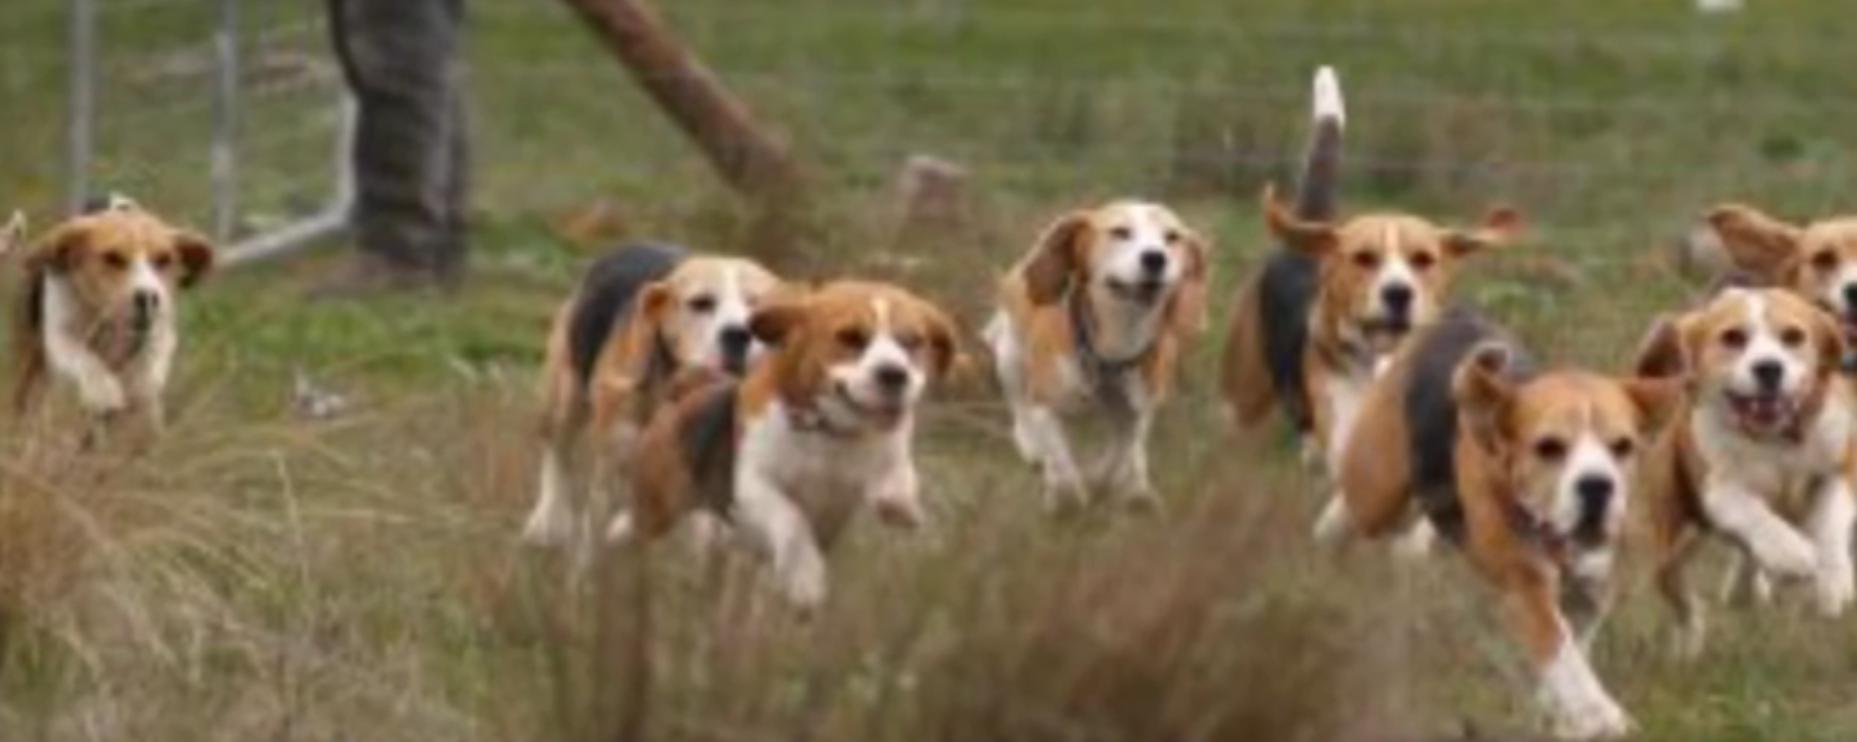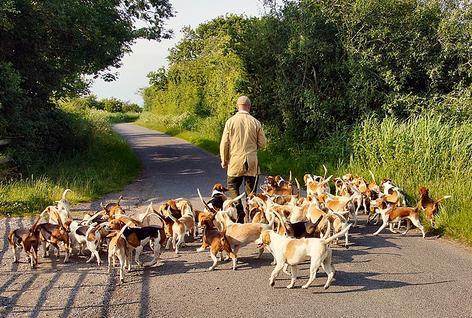The first image is the image on the left, the second image is the image on the right. Examine the images to the left and right. Is the description "No humans are in sight in one of the images of hounds." accurate? Answer yes or no. No. 